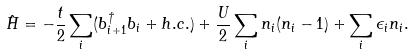<formula> <loc_0><loc_0><loc_500><loc_500>\hat { H } = - \frac { t } { 2 } \sum _ { i } ( b ^ { \dagger } _ { i + 1 } b _ { i } + h . c . ) + \frac { U } { 2 } \sum _ { i } n _ { i } ( n _ { i } - 1 ) + \sum _ { i } \epsilon _ { i } n _ { i } .</formula> 